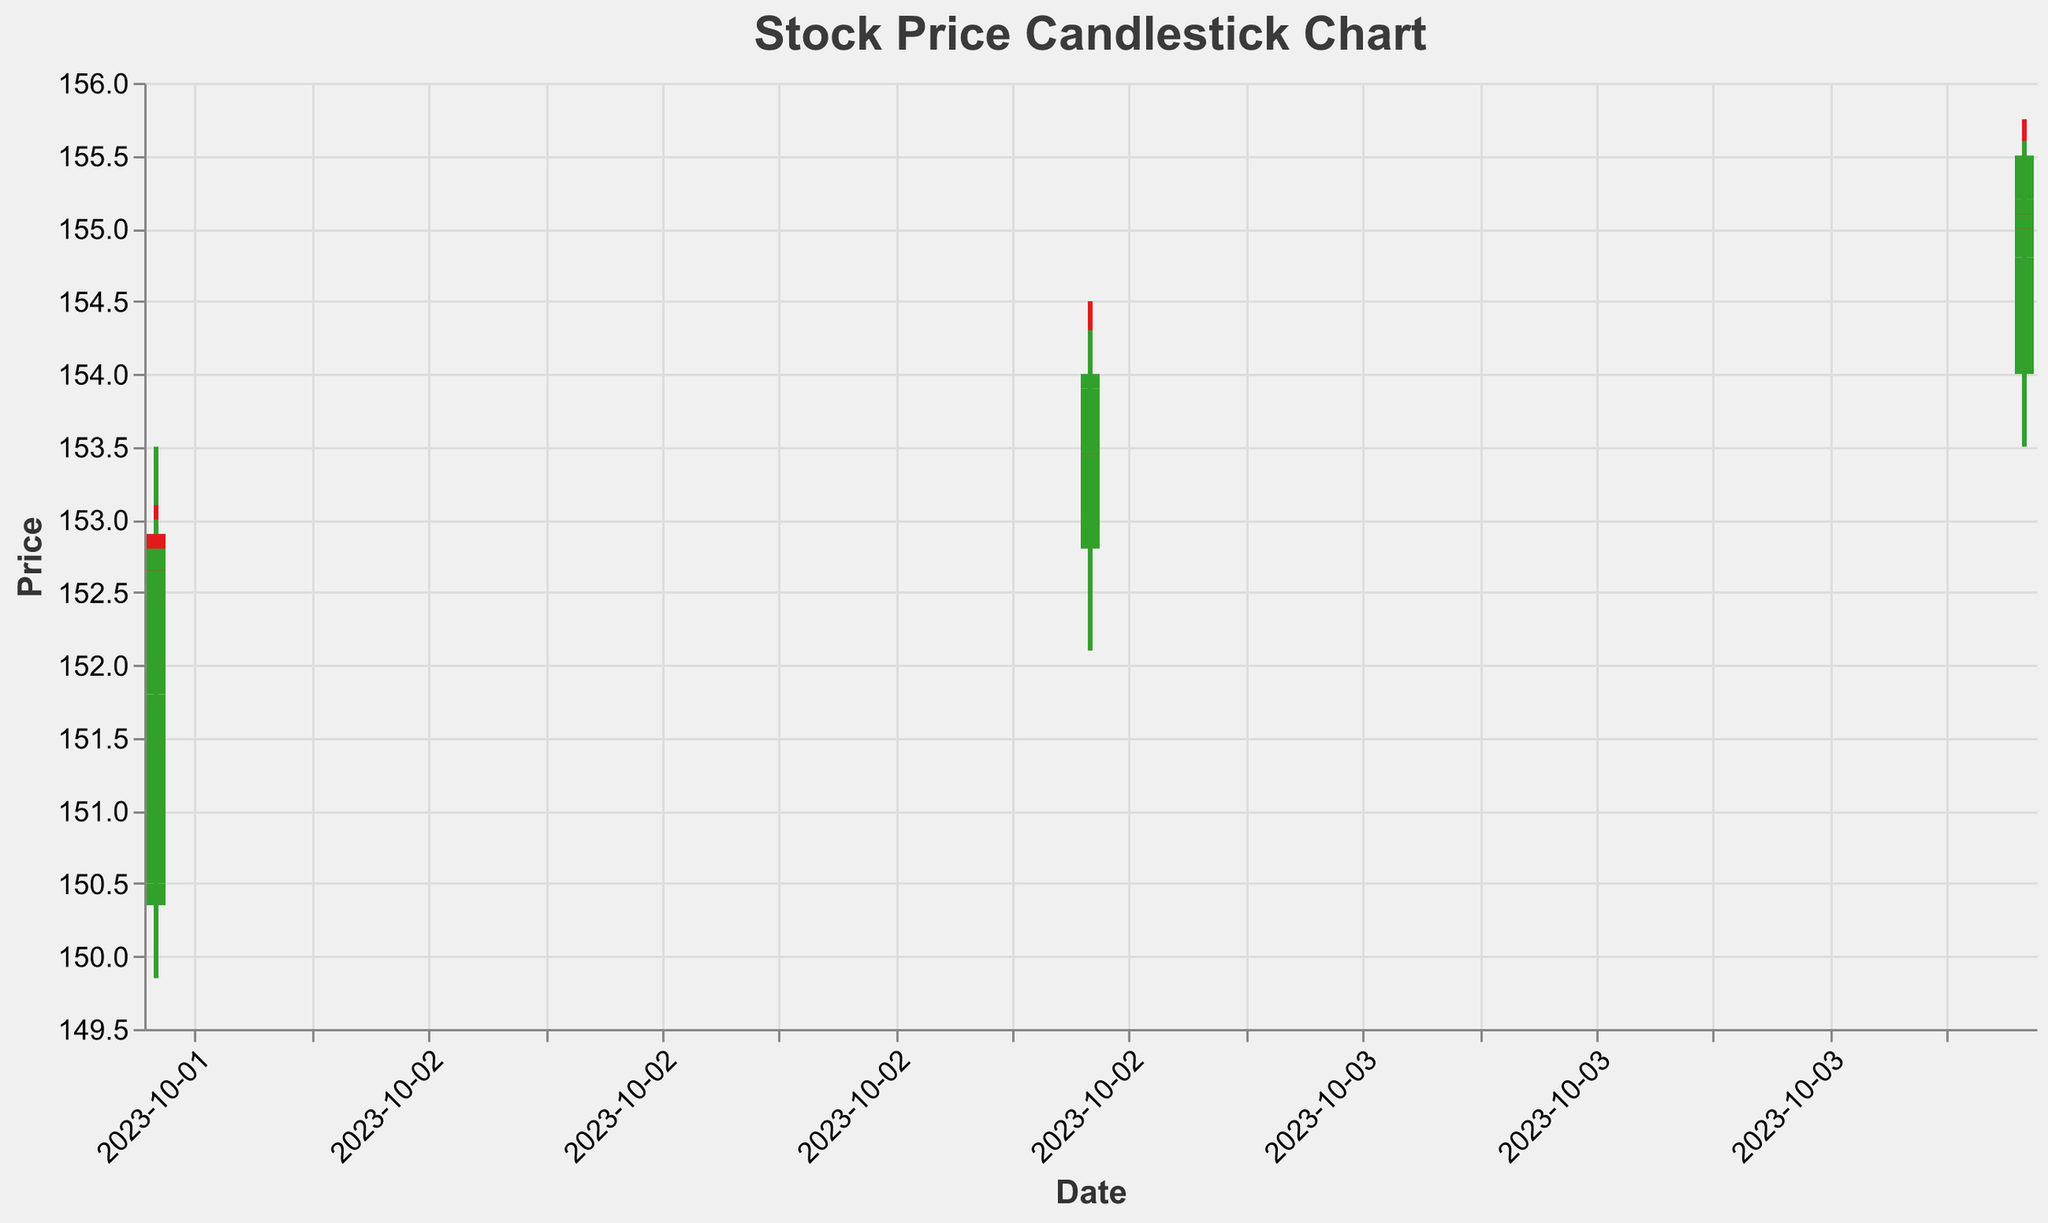What is the title of the candlestick chart? The title is typically placed at the top of the chart and is made to clearly indicate what the chart represents. In this case, the title is provided explicitly in the chart configuration.
Answer: Stock Price Candlestick Chart What is the highest price recorded on October 2nd, 2023? To determine the highest price on October 2nd, scan the data for all the 'High' values on that date and find the maximum. The highest recorded price is 153.20.
Answer: 153.20 Which day shows a higher closing price, October 3rd or October 4th? Compare the last closing prices of both days. The closing price on October 3rd is 154.00, while on October 4th, it is 155.50. Thus, October 4th has a higher closing price.
Answer: October 4th How many data points are there for each trading day shown in the chart? The data indicates that for each day, trading hours from 09:30 to 15:30 are provided in hourly intervals. Count the entries for a single day to establish this pattern.
Answer: 7 On which day and time was the highest volume of trading recorded? Review the 'Volume' field across all data points to find the highest value. The highest volume is 800,000 at 09:30 on October 2nd.
Answer: October 2nd, 09:30 What is the difference between the highest and lowest closing prices over the three days? Identify the highest closing price (155.50 on Oct 4, 15:30) and the lowest closing price (150.50 on Oct 2, 09:30), then compute the difference. 155.50 - 150.50 = 5.00
Answer: 5.00 Compare the volume of the first trading hour on October 2nd and October 3rd. Which day had the higher trading volume in the first hour? Look at the 'Volume' value for the 09:30 entries on both days. October 2nd has a volume of 800,000, while October 3rd has 700,000. October 2nd has a higher volume.
Answer: October 2nd Was the closing price higher than the opening price on October 3rd, 11:30? Check the opening price (153.75) and the closing price (153.50) for this time. Here, the closing price is lower than the opening price.
Answer: No What is the total trading volume for October 4th? Sum the 'Volume' values for all entries on October 4th. The values are 720,000 + 700,000 + 600,000 + 550,000 + 500,000 + 450,000 + 400,000 = 3,920,000
Answer: 3,920,000 Between October 2nd and October 4th, which date has more green candlesticks (positive intraday change)? Identify 'green' candlesticks by checking if the Close price is higher than the Open price for each date. October 2nd has 4 positive candlesticks, and October 4th has 5. October 4th has more green candlesticks.
Answer: October 4th 